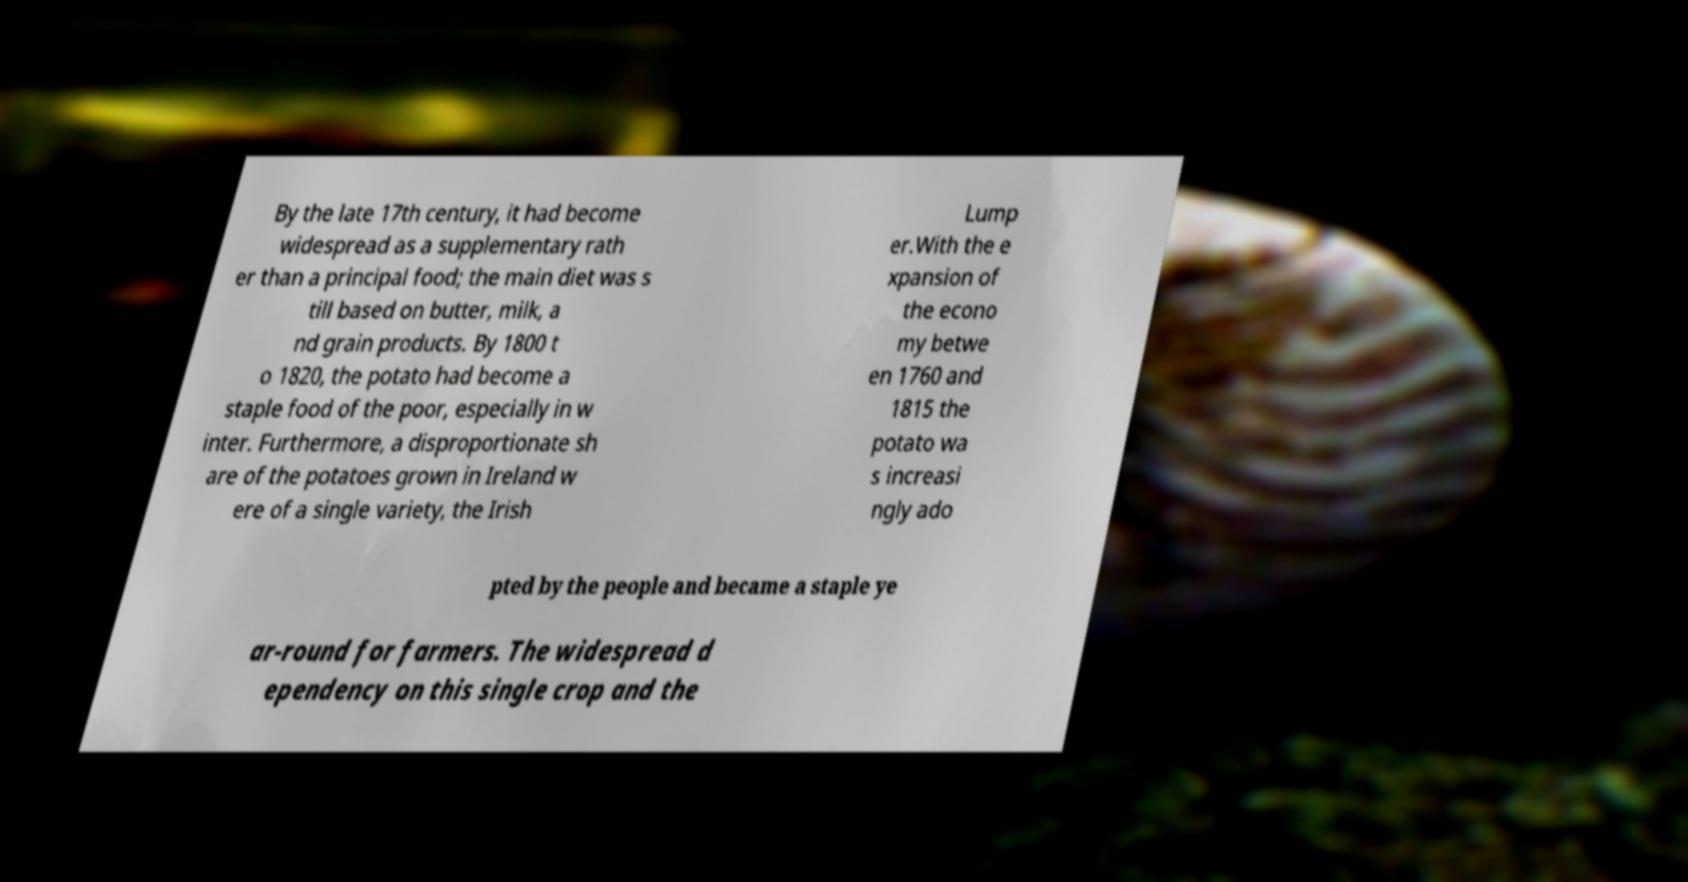I need the written content from this picture converted into text. Can you do that? By the late 17th century, it had become widespread as a supplementary rath er than a principal food; the main diet was s till based on butter, milk, a nd grain products. By 1800 t o 1820, the potato had become a staple food of the poor, especially in w inter. Furthermore, a disproportionate sh are of the potatoes grown in Ireland w ere of a single variety, the Irish Lump er.With the e xpansion of the econo my betwe en 1760 and 1815 the potato wa s increasi ngly ado pted by the people and became a staple ye ar-round for farmers. The widespread d ependency on this single crop and the 